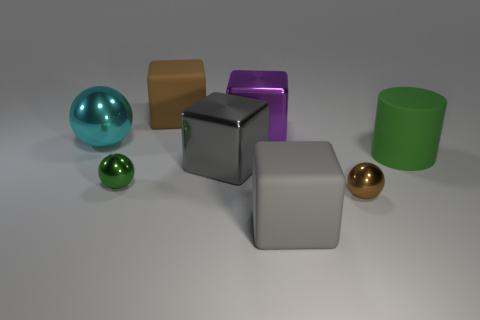Subtract 1 cubes. How many cubes are left? 3 Add 2 tiny purple rubber spheres. How many objects exist? 10 Subtract all balls. How many objects are left? 5 Subtract all gray blocks. Subtract all small green metal blocks. How many objects are left? 6 Add 3 large cylinders. How many large cylinders are left? 4 Add 8 small brown balls. How many small brown balls exist? 9 Subtract 0 purple cylinders. How many objects are left? 8 